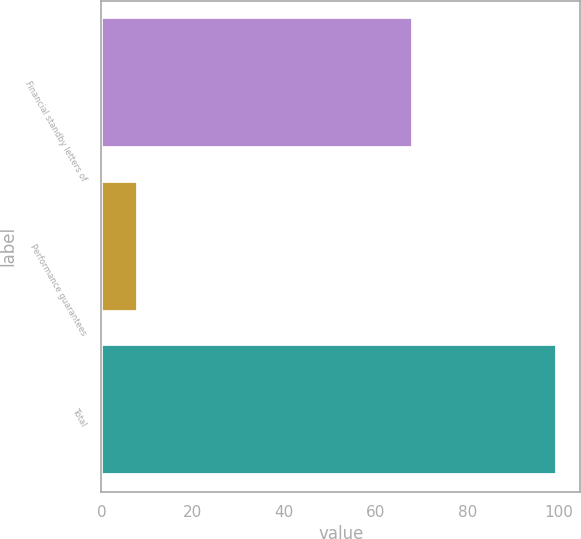Convert chart. <chart><loc_0><loc_0><loc_500><loc_500><bar_chart><fcel>Financial standby letters of<fcel>Performance guarantees<fcel>Total<nl><fcel>68.1<fcel>7.9<fcel>99.7<nl></chart> 